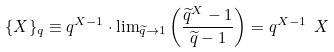Convert formula to latex. <formula><loc_0><loc_0><loc_500><loc_500>\{ X \} _ { q } \equiv q ^ { X - 1 } \cdot { \lim } _ { \widetilde { q } \to 1 } \left ( \frac { \widetilde { q } ^ { X } - 1 } { \widetilde { q } - 1 } \right ) = q ^ { X - 1 } \ X \</formula> 